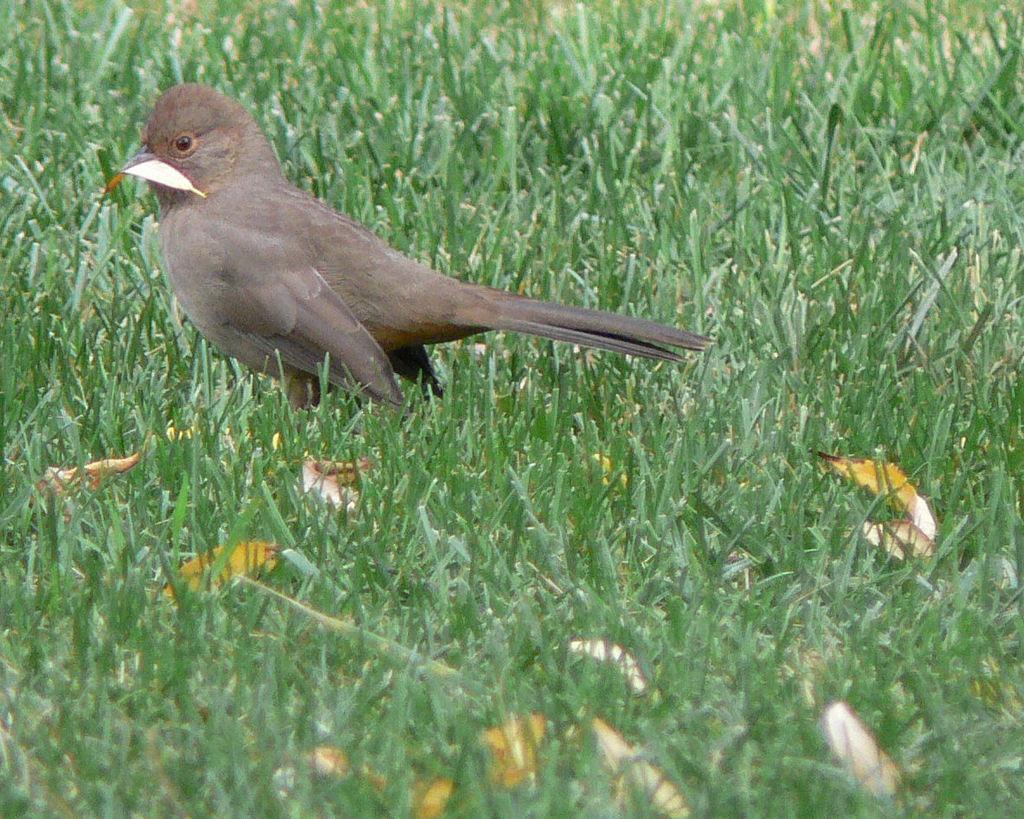In one or two sentences, can you explain what this image depicts? In this picture I can see a bird, grass and leaves. I can also see a leaf on the bird. 